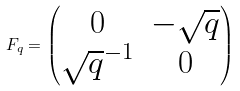Convert formula to latex. <formula><loc_0><loc_0><loc_500><loc_500>F _ { q } = \begin{pmatrix} 0 & - \sqrt { q } \\ { \sqrt { q } } ^ { - 1 } & 0 \end{pmatrix}</formula> 